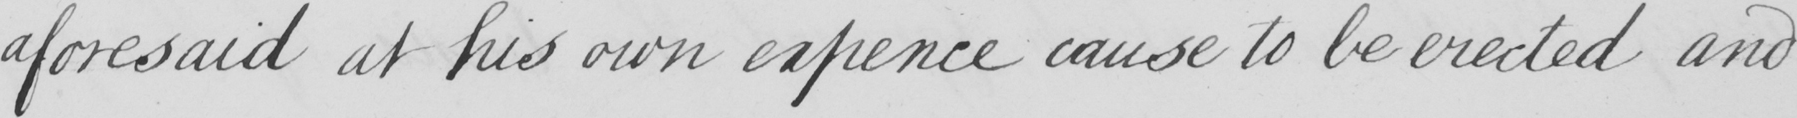Can you tell me what this handwritten text says? aforesaid at his own expence cause to be erected and 